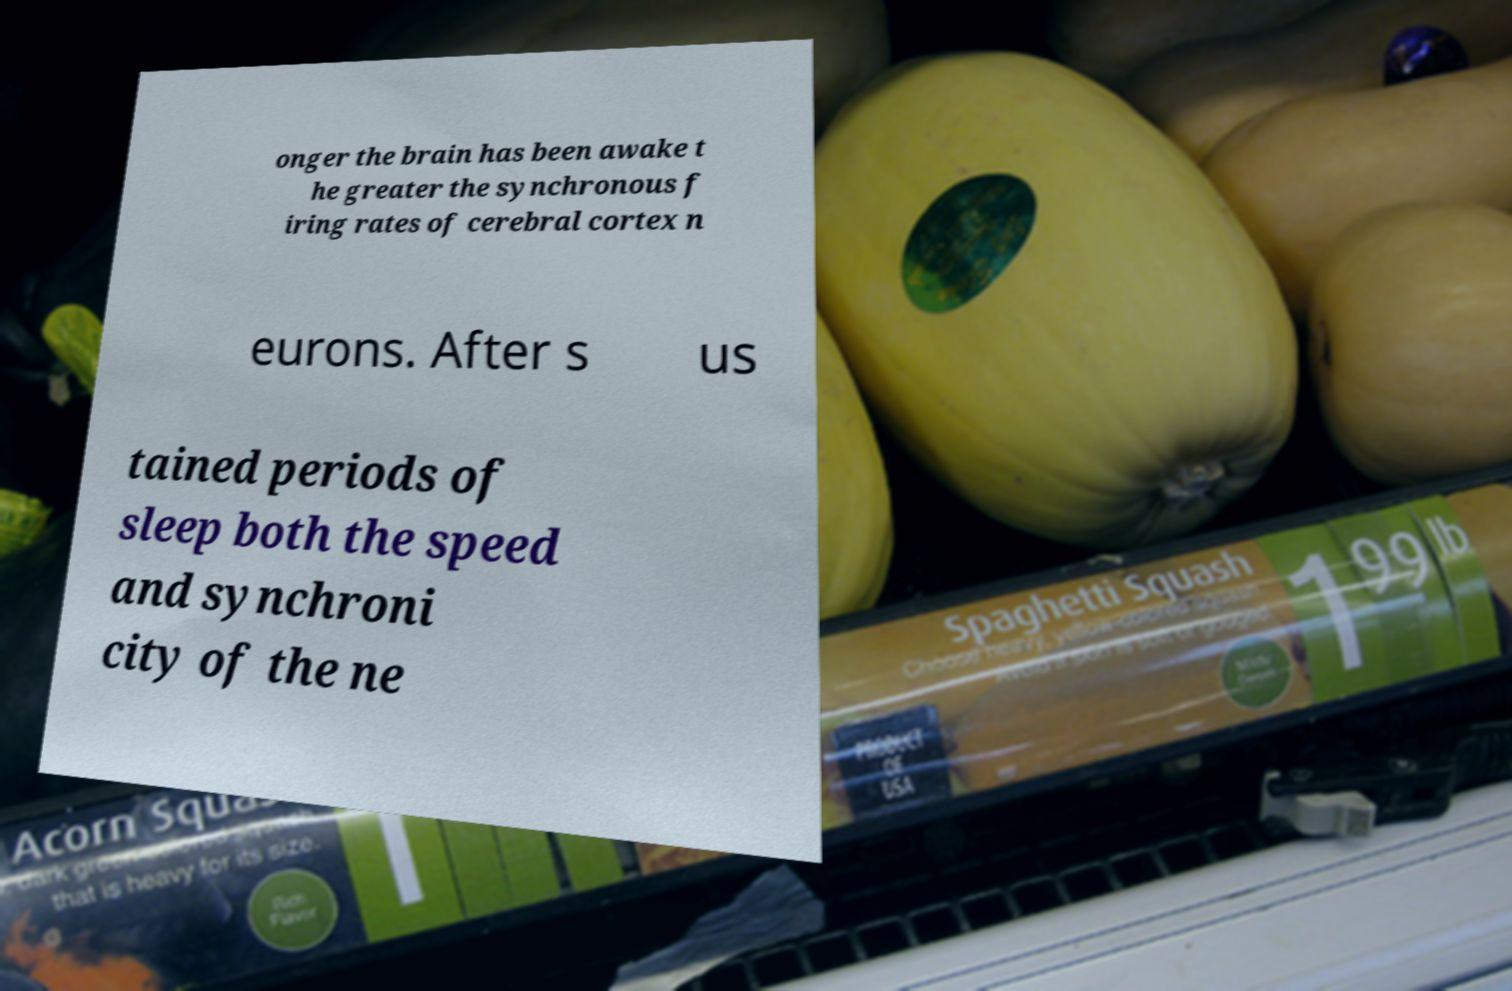I need the written content from this picture converted into text. Can you do that? onger the brain has been awake t he greater the synchronous f iring rates of cerebral cortex n eurons. After s us tained periods of sleep both the speed and synchroni city of the ne 